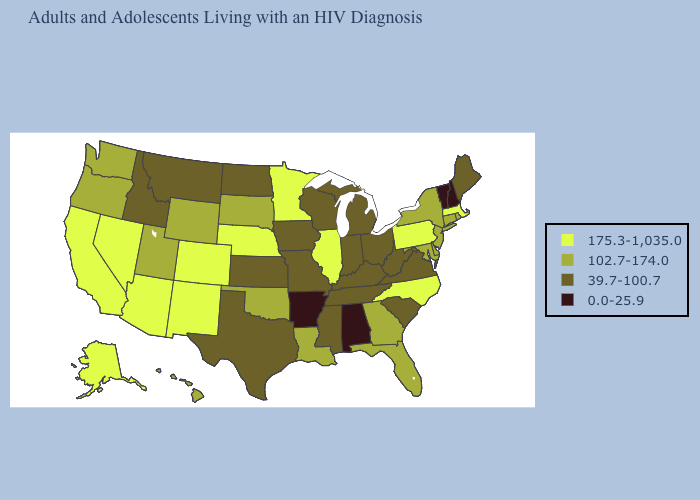What is the value of Missouri?
Concise answer only. 39.7-100.7. What is the value of Kentucky?
Short answer required. 39.7-100.7. Does Wyoming have the highest value in the USA?
Be succinct. No. Does Alabama have the lowest value in the USA?
Concise answer only. Yes. Which states have the lowest value in the West?
Be succinct. Idaho, Montana. Name the states that have a value in the range 102.7-174.0?
Be succinct. Connecticut, Delaware, Florida, Georgia, Hawaii, Louisiana, Maryland, New Jersey, New York, Oklahoma, Oregon, Rhode Island, South Dakota, Utah, Washington, Wyoming. Does South Carolina have the same value as Kansas?
Keep it brief. Yes. What is the value of Kentucky?
Give a very brief answer. 39.7-100.7. Among the states that border California , which have the highest value?
Keep it brief. Arizona, Nevada. Name the states that have a value in the range 102.7-174.0?
Answer briefly. Connecticut, Delaware, Florida, Georgia, Hawaii, Louisiana, Maryland, New Jersey, New York, Oklahoma, Oregon, Rhode Island, South Dakota, Utah, Washington, Wyoming. What is the lowest value in the South?
Short answer required. 0.0-25.9. Name the states that have a value in the range 0.0-25.9?
Be succinct. Alabama, Arkansas, New Hampshire, Vermont. Name the states that have a value in the range 175.3-1,035.0?
Answer briefly. Alaska, Arizona, California, Colorado, Illinois, Massachusetts, Minnesota, Nebraska, Nevada, New Mexico, North Carolina, Pennsylvania. Does Nebraska have the lowest value in the MidWest?
Quick response, please. No. 